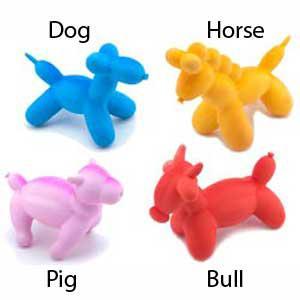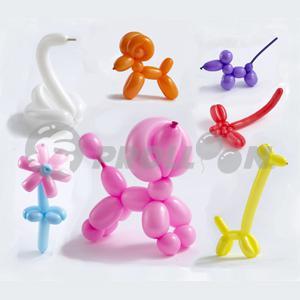The first image is the image on the left, the second image is the image on the right. Given the left and right images, does the statement "One of the image has exactly four balloons." hold true? Answer yes or no. Yes. 